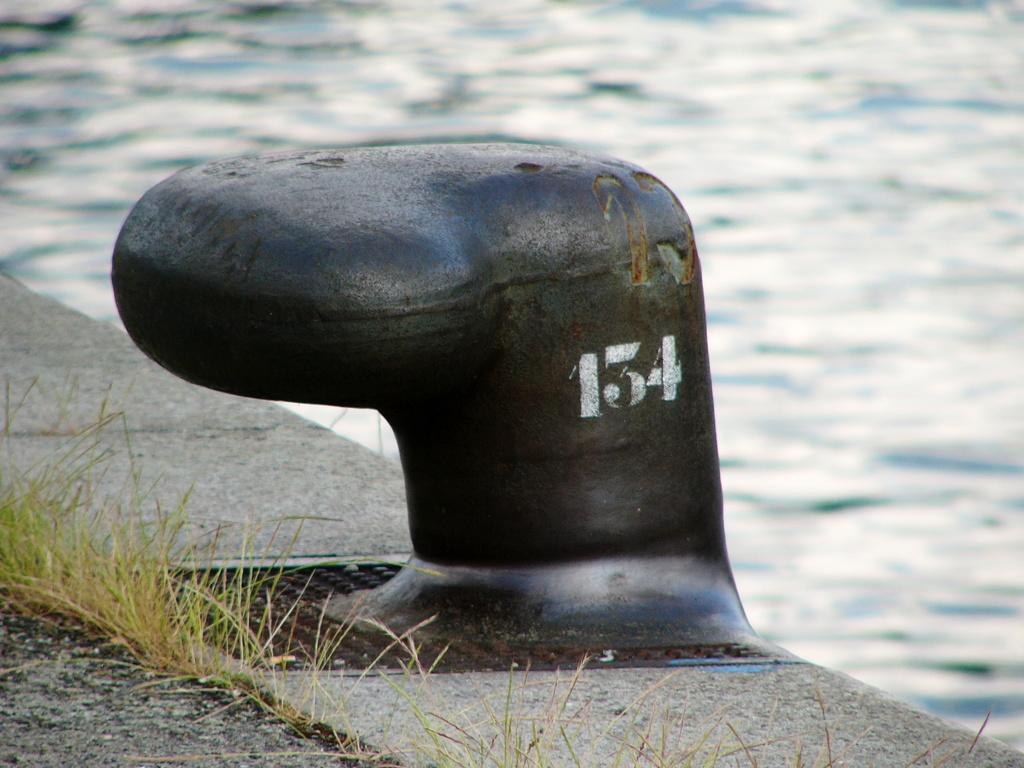What is the black object with writing on it in the image? There is a black object with writing on it in the image. Can you describe the background of the image? The background is blurry. What type of natural environment is visible in the image? There is water and grass visible in the image. What type of arithmetic problem is being solved by the pig in the image? There is no pig or arithmetic problem present in the image. What type of police vehicle can be seen in the image? There is no police vehicle present in the image. 